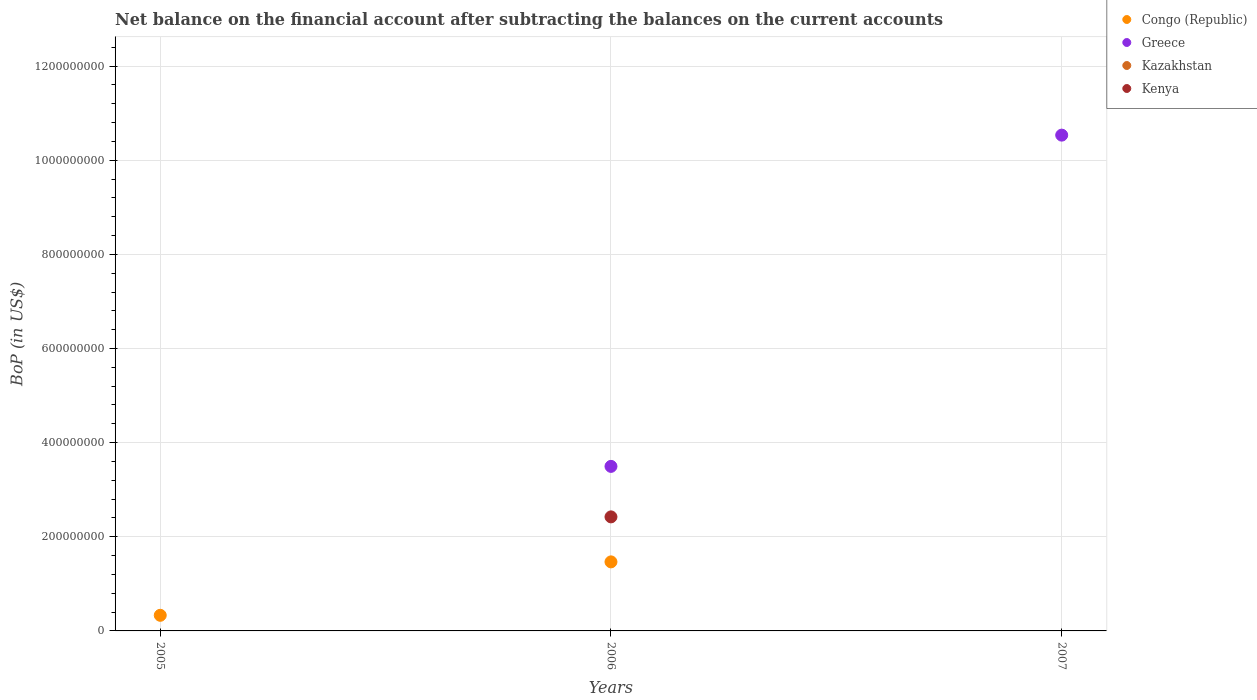Is the number of dotlines equal to the number of legend labels?
Provide a short and direct response. No. What is the Balance of Payments in Greece in 2006?
Provide a succinct answer. 3.50e+08. Across all years, what is the maximum Balance of Payments in Greece?
Provide a short and direct response. 1.05e+09. What is the total Balance of Payments in Greece in the graph?
Provide a succinct answer. 1.40e+09. What is the difference between the Balance of Payments in Congo (Republic) in 2005 and that in 2006?
Keep it short and to the point. -1.14e+08. What is the difference between the Balance of Payments in Greece in 2006 and the Balance of Payments in Kazakhstan in 2005?
Provide a short and direct response. 3.50e+08. In the year 2006, what is the difference between the Balance of Payments in Kenya and Balance of Payments in Greece?
Ensure brevity in your answer.  -1.07e+08. In how many years, is the Balance of Payments in Greece greater than 200000000 US$?
Your response must be concise. 2. What is the ratio of the Balance of Payments in Congo (Republic) in 2005 to that in 2006?
Your response must be concise. 0.23. Is the Balance of Payments in Congo (Republic) in 2005 less than that in 2006?
Your answer should be compact. Yes. What is the difference between the highest and the lowest Balance of Payments in Kenya?
Provide a succinct answer. 2.42e+08. Does the Balance of Payments in Greece monotonically increase over the years?
Your response must be concise. Yes. Is the Balance of Payments in Kenya strictly greater than the Balance of Payments in Greece over the years?
Give a very brief answer. No. Is the Balance of Payments in Congo (Republic) strictly less than the Balance of Payments in Greece over the years?
Offer a terse response. No. How many dotlines are there?
Your answer should be very brief. 3. How many years are there in the graph?
Your answer should be very brief. 3. Does the graph contain any zero values?
Offer a terse response. Yes. How many legend labels are there?
Ensure brevity in your answer.  4. What is the title of the graph?
Offer a terse response. Net balance on the financial account after subtracting the balances on the current accounts. Does "Rwanda" appear as one of the legend labels in the graph?
Your response must be concise. No. What is the label or title of the Y-axis?
Your answer should be very brief. BoP (in US$). What is the BoP (in US$) of Congo (Republic) in 2005?
Make the answer very short. 3.32e+07. What is the BoP (in US$) of Greece in 2005?
Make the answer very short. 0. What is the BoP (in US$) of Kenya in 2005?
Your response must be concise. 0. What is the BoP (in US$) in Congo (Republic) in 2006?
Your response must be concise. 1.47e+08. What is the BoP (in US$) in Greece in 2006?
Provide a short and direct response. 3.50e+08. What is the BoP (in US$) in Kenya in 2006?
Provide a short and direct response. 2.42e+08. What is the BoP (in US$) in Congo (Republic) in 2007?
Ensure brevity in your answer.  0. What is the BoP (in US$) in Greece in 2007?
Your answer should be very brief. 1.05e+09. Across all years, what is the maximum BoP (in US$) in Congo (Republic)?
Make the answer very short. 1.47e+08. Across all years, what is the maximum BoP (in US$) in Greece?
Offer a very short reply. 1.05e+09. Across all years, what is the maximum BoP (in US$) of Kenya?
Offer a terse response. 2.42e+08. Across all years, what is the minimum BoP (in US$) in Congo (Republic)?
Your answer should be compact. 0. What is the total BoP (in US$) in Congo (Republic) in the graph?
Your response must be concise. 1.80e+08. What is the total BoP (in US$) of Greece in the graph?
Your response must be concise. 1.40e+09. What is the total BoP (in US$) in Kenya in the graph?
Provide a short and direct response. 2.42e+08. What is the difference between the BoP (in US$) of Congo (Republic) in 2005 and that in 2006?
Make the answer very short. -1.14e+08. What is the difference between the BoP (in US$) in Greece in 2006 and that in 2007?
Your response must be concise. -7.04e+08. What is the difference between the BoP (in US$) of Congo (Republic) in 2005 and the BoP (in US$) of Greece in 2006?
Give a very brief answer. -3.16e+08. What is the difference between the BoP (in US$) of Congo (Republic) in 2005 and the BoP (in US$) of Kenya in 2006?
Give a very brief answer. -2.09e+08. What is the difference between the BoP (in US$) in Congo (Republic) in 2005 and the BoP (in US$) in Greece in 2007?
Ensure brevity in your answer.  -1.02e+09. What is the difference between the BoP (in US$) of Congo (Republic) in 2006 and the BoP (in US$) of Greece in 2007?
Provide a succinct answer. -9.07e+08. What is the average BoP (in US$) in Congo (Republic) per year?
Offer a very short reply. 6.00e+07. What is the average BoP (in US$) in Greece per year?
Give a very brief answer. 4.68e+08. What is the average BoP (in US$) in Kenya per year?
Your answer should be very brief. 8.08e+07. In the year 2006, what is the difference between the BoP (in US$) in Congo (Republic) and BoP (in US$) in Greece?
Ensure brevity in your answer.  -2.03e+08. In the year 2006, what is the difference between the BoP (in US$) in Congo (Republic) and BoP (in US$) in Kenya?
Your answer should be compact. -9.56e+07. In the year 2006, what is the difference between the BoP (in US$) of Greece and BoP (in US$) of Kenya?
Offer a terse response. 1.07e+08. What is the ratio of the BoP (in US$) in Congo (Republic) in 2005 to that in 2006?
Ensure brevity in your answer.  0.23. What is the ratio of the BoP (in US$) in Greece in 2006 to that in 2007?
Your answer should be very brief. 0.33. What is the difference between the highest and the lowest BoP (in US$) in Congo (Republic)?
Make the answer very short. 1.47e+08. What is the difference between the highest and the lowest BoP (in US$) of Greece?
Your answer should be very brief. 1.05e+09. What is the difference between the highest and the lowest BoP (in US$) in Kenya?
Keep it short and to the point. 2.42e+08. 